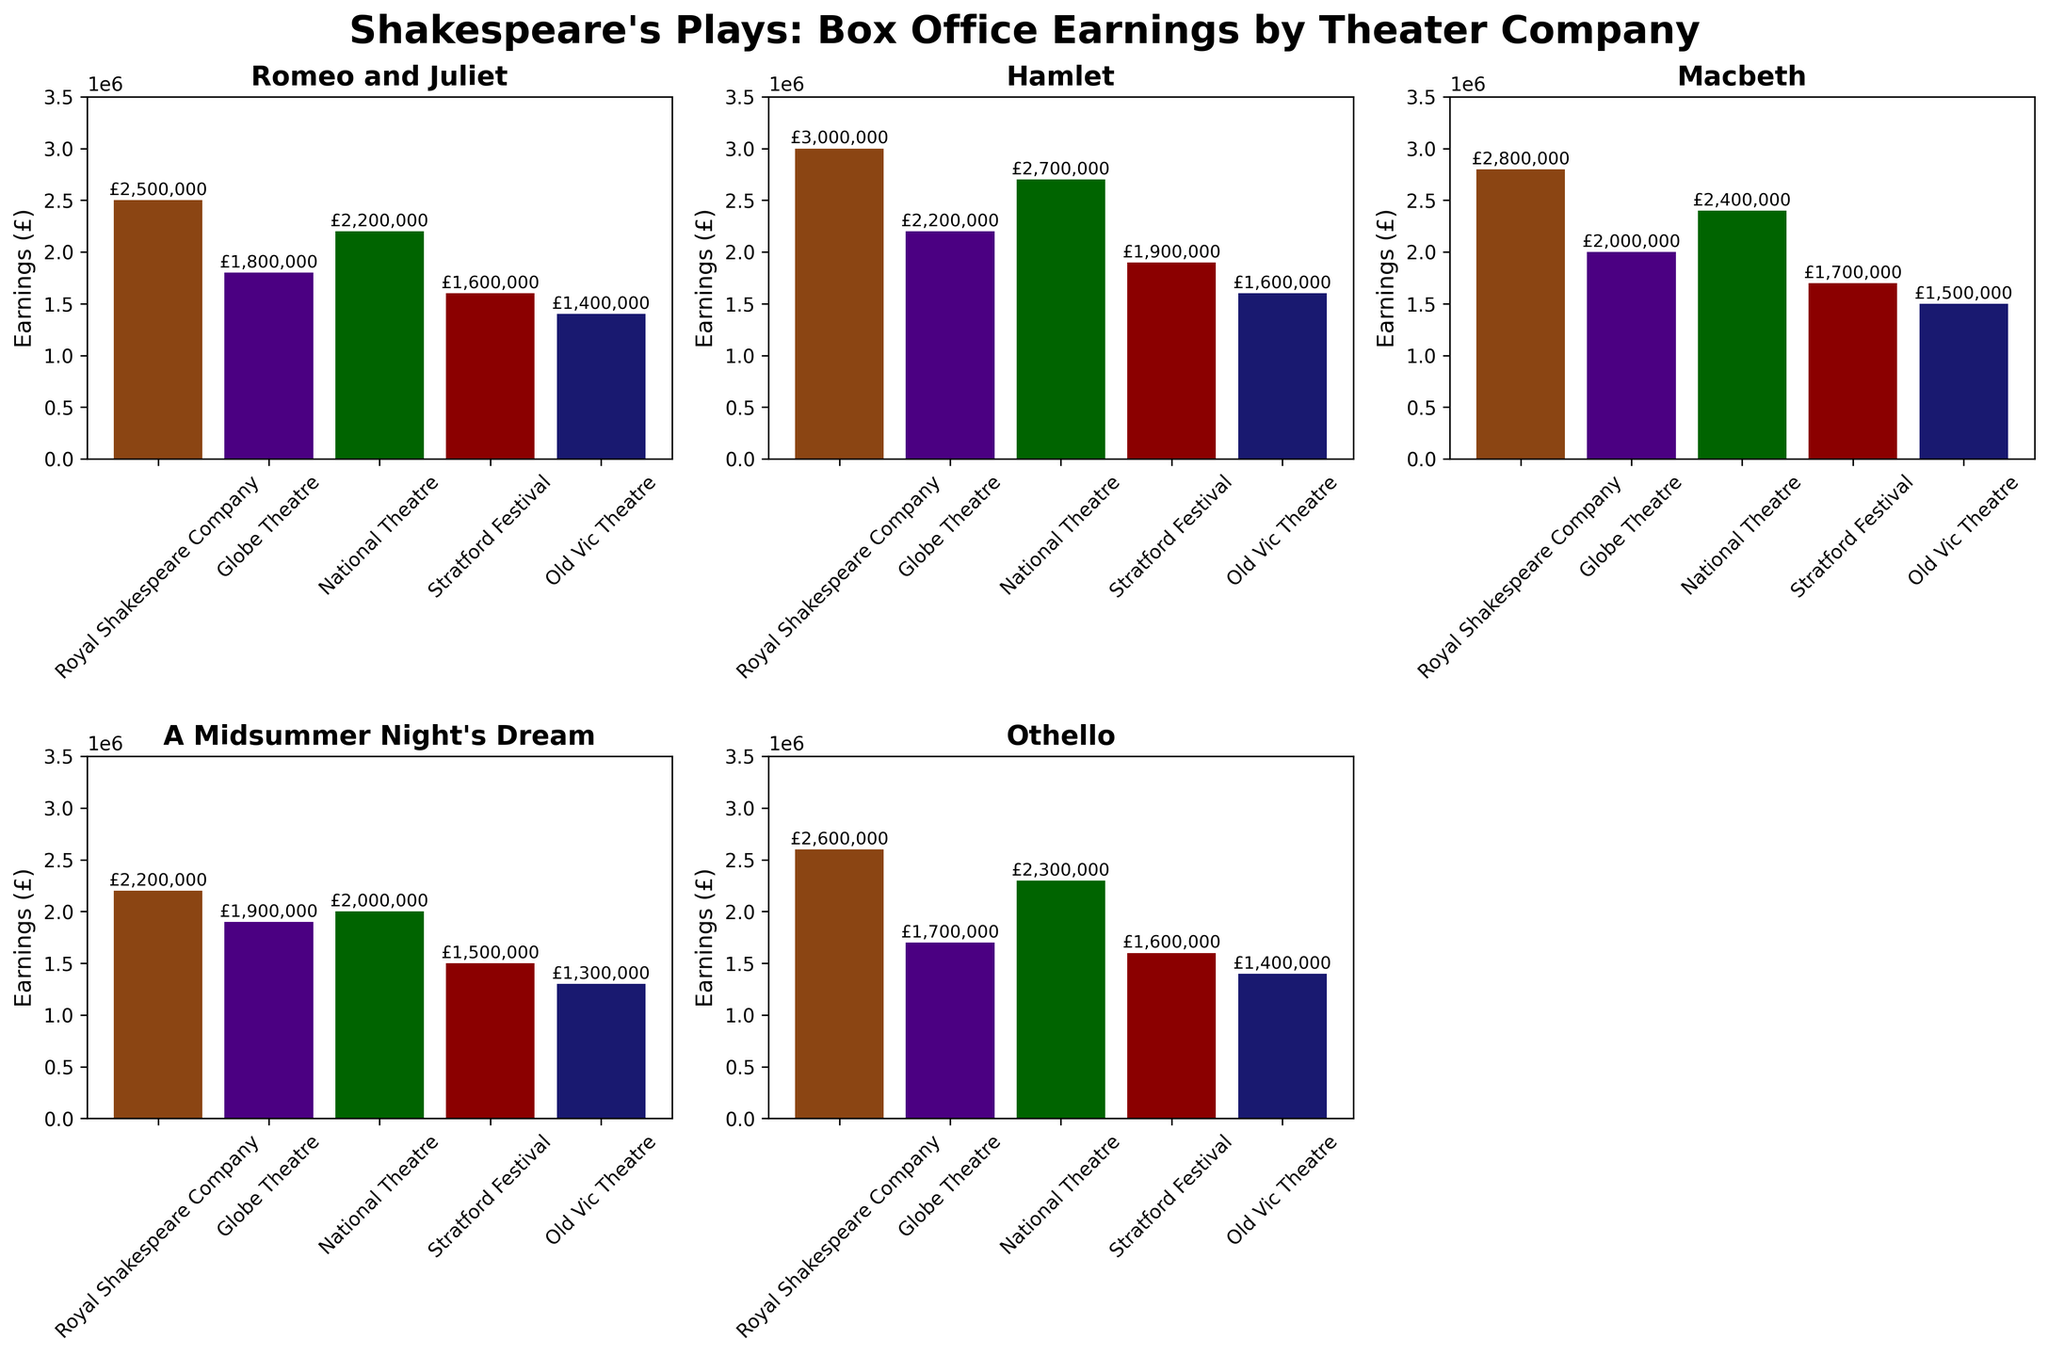Which play had the highest box office earnings for the Royal Shakespeare Company? The Royal Shakespeare Company's earnings for the plays are shown as different bars in the figure. From the subplot corresponding to the Royal Shakespeare Company, the tallest bar is for Hamlet.
Answer: Hamlet What is the difference in earnings between 'Romeo and Juliet' and 'Macbeth' at the Globe Theatre? Look at the subplot for 'Romeo and Juliet' and 'Macbeth' at the Globe Theatre. The earnings are £1,800,000 and £2,000,000 respectively. Subtract to find the difference: £2,000,000 - £1,800,000.
Answer: £200,000 Which theater company earned the least for 'Othello'? In the subplot for 'Othello', find the shortest bar representing different theater companies. The shortest bar corresponds to Old Vic Theatre.
Answer: Old Vic Theatre What is the average earnings for the National Theatre across all plays? Add the earnings for National Theatre for each play: £2,200,000 + £2,700,000 + £2,400,000 + £2,000,000 + £2,300,000. Then divide by the number of plays (5).
Answer: £2,320,000 Is there any play where the Stratford Festival earned more than the National Theatre? Compare the earnings of Stratford Festival and National Theatre for each play. Stratford Festival's earnings are lower in every play in comparison to National Theatre's earnings.
Answer: No Which play had the highest earnings across all theater companies? Check each subplot for the maximum value. 'Hamlet' performed by the Royal Shakespeare Company has the highest earning of £3,000,000.
Answer: Hamlet How much more did the Royal Shakespeare Company earn from 'A Midsummer Night's Dream' compared to the Old Vic Theatre? The earnings for 'A Midsummer Night's Dream' are £2,200,000 for Royal Shakespeare Company and £1,300,000 for Old Vic Theatre. Calculate the difference: £2,200,000 - £1,300,000.
Answer: £900,000 What is the total box office earnings for the Globe Theatre across all Shakespeare's plays? Add the earnings for the Globe Theatre for each play: £1,800,000 + £2,200,000 + £2,000,000 + £1,900,000 + £1,700,000.
Answer: £9,600,000 Which theater company's earnings show the smallest deviation among the five plays? Visual inspection shows the bars for Stratford Festival are relatively closest in height compared to other companies, indicating smaller deviation.
Answer: Stratford Festival Does the Old Vic Theatre earn more from 'Hamlet' or 'Othello'? Compare the heights of the bars for 'Hamlet' and 'Othello' in Old Vic Theatre's subplot. The bar for 'Hamlet' is higher.
Answer: Hamlet 